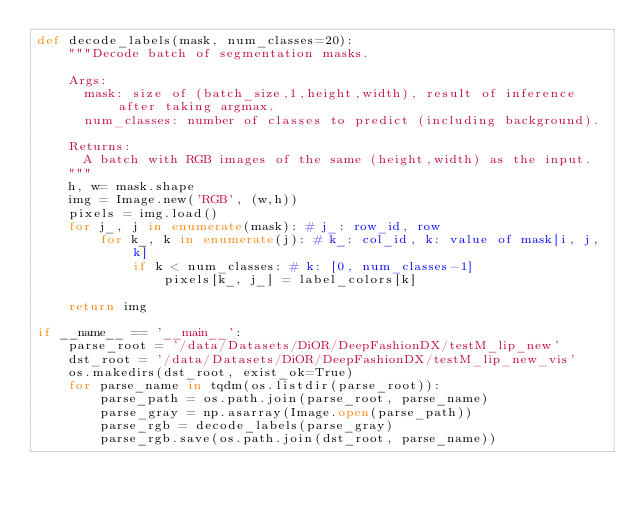Convert code to text. <code><loc_0><loc_0><loc_500><loc_500><_Python_>def decode_labels(mask, num_classes=20):
    """Decode batch of segmentation masks.
    
    Args:
      mask: size of (batch_size,1,height,width), result of inference after taking argmax.
      num_classes: number of classes to predict (including background).
    
    Returns:
      A batch with RGB images of the same (height,width) as the input. 
    """
    h, w= mask.shape
    img = Image.new('RGB', (w,h))
    pixels = img.load()
    for j_, j in enumerate(mask): # j_: row_id, row
        for k_, k in enumerate(j): # k_: col_id, k: value of mask[i, j, k]
            if k < num_classes: # k: [0, num_classes-1]
                pixels[k_, j_] = label_colors[k]
    
    return img

if __name__ == '__main__':
    parse_root = '/data/Datasets/DiOR/DeepFashionDX/testM_lip_new'
    dst_root = '/data/Datasets/DiOR/DeepFashionDX/testM_lip_new_vis'
    os.makedirs(dst_root, exist_ok=True)
    for parse_name in tqdm(os.listdir(parse_root)):
        parse_path = os.path.join(parse_root, parse_name)
        parse_gray = np.asarray(Image.open(parse_path))
        parse_rgb = decode_labels(parse_gray)
        parse_rgb.save(os.path.join(dst_root, parse_name))</code> 